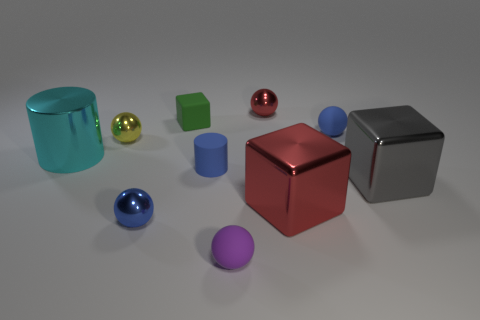Subtract all small purple spheres. How many spheres are left? 4 Subtract 2 spheres. How many spheres are left? 3 Subtract all purple balls. How many balls are left? 4 Subtract all purple cylinders. Subtract all purple balls. How many cylinders are left? 2 Subtract all cylinders. How many objects are left? 8 Add 1 tiny cubes. How many tiny cubes are left? 2 Add 6 big cyan cylinders. How many big cyan cylinders exist? 7 Subtract 1 green blocks. How many objects are left? 9 Subtract all tiny purple matte balls. Subtract all gray blocks. How many objects are left? 8 